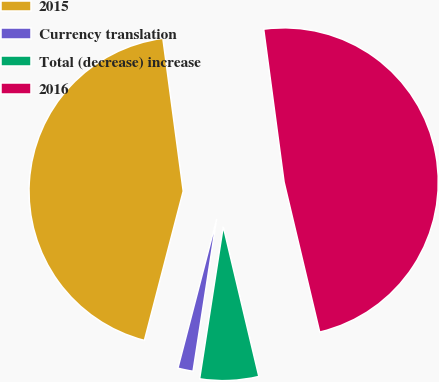<chart> <loc_0><loc_0><loc_500><loc_500><pie_chart><fcel>2015<fcel>Currency translation<fcel>Total (decrease) increase<fcel>2016<nl><fcel>43.84%<fcel>1.6%<fcel>6.16%<fcel>48.4%<nl></chart> 